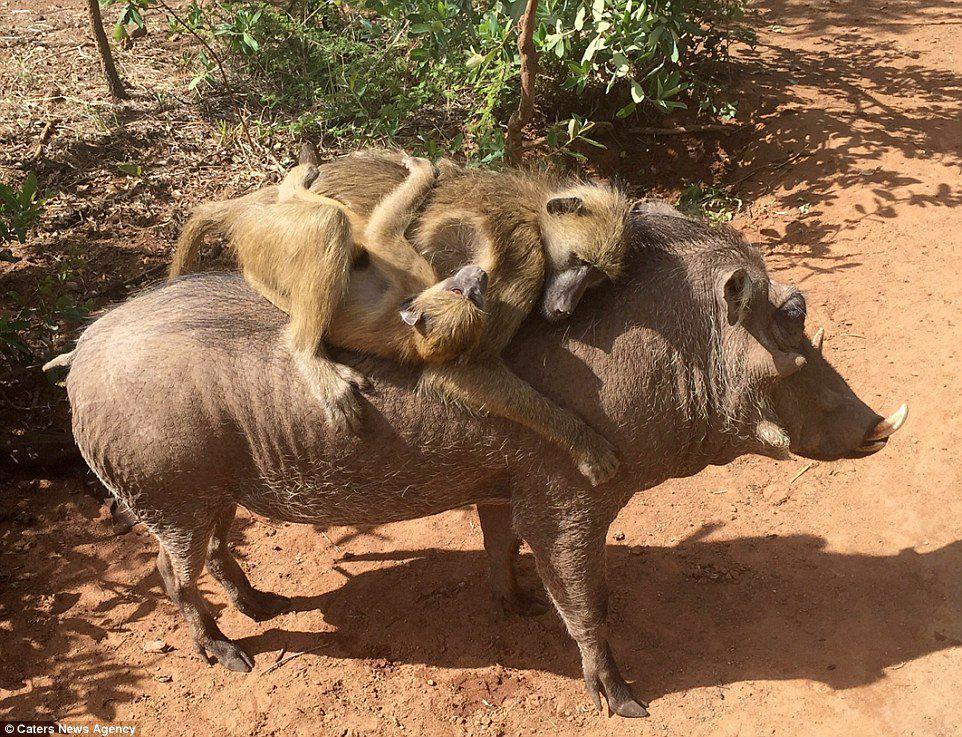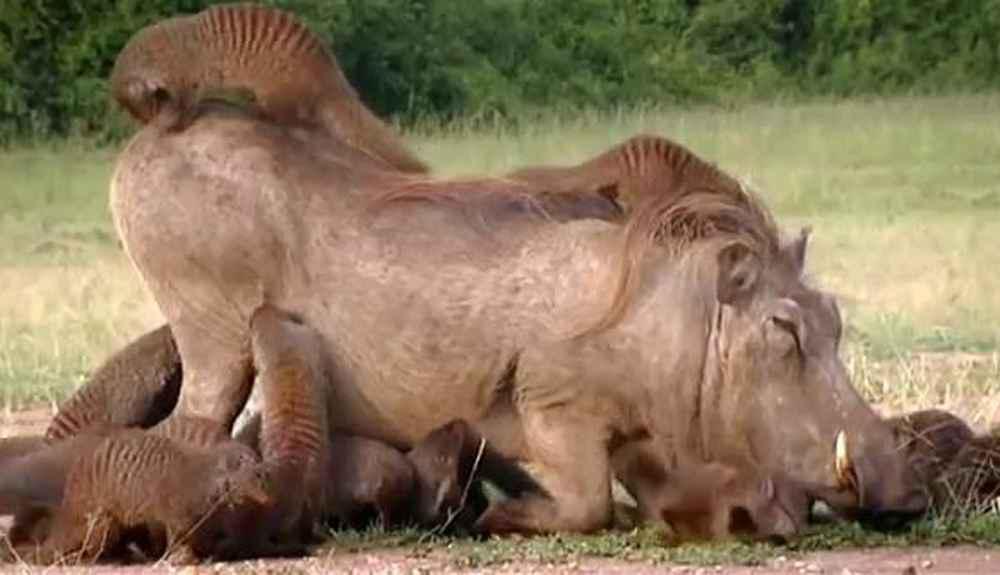The first image is the image on the left, the second image is the image on the right. Considering the images on both sides, is "A hunter is posing near the wild pig in the image on the right." valid? Answer yes or no. No. The first image is the image on the left, the second image is the image on the right. Considering the images on both sides, is "An image shows exactly one person posed behind a killed warthog." valid? Answer yes or no. No. 